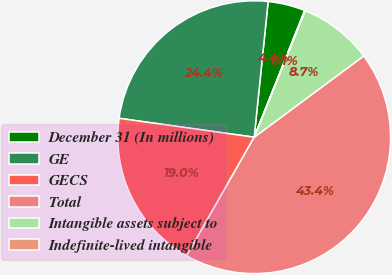Convert chart. <chart><loc_0><loc_0><loc_500><loc_500><pie_chart><fcel>December 31 (In millions)<fcel>GE<fcel>GECS<fcel>Total<fcel>Intangible assets subject to<fcel>Indefinite-lived intangible<nl><fcel>4.4%<fcel>24.42%<fcel>18.98%<fcel>43.4%<fcel>8.74%<fcel>0.07%<nl></chart> 